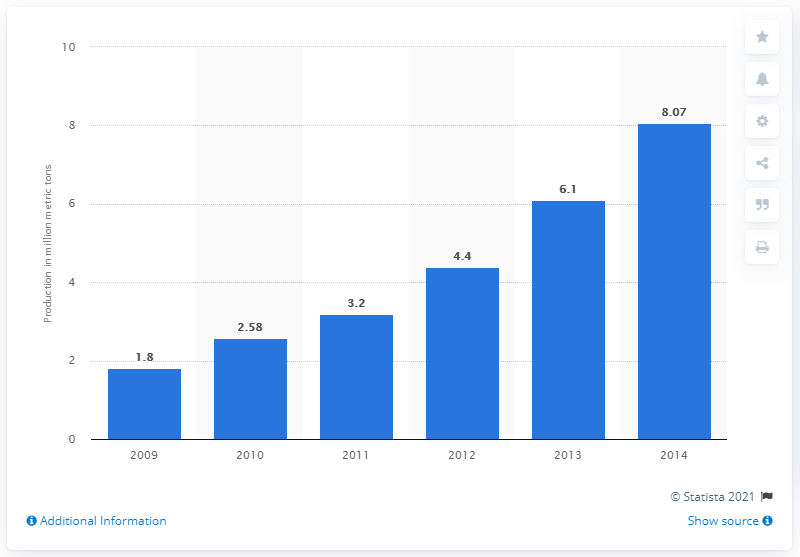Identify some key points in this picture. The import of wood pellets into the 28 member states of the European Union ceased in 2014. 